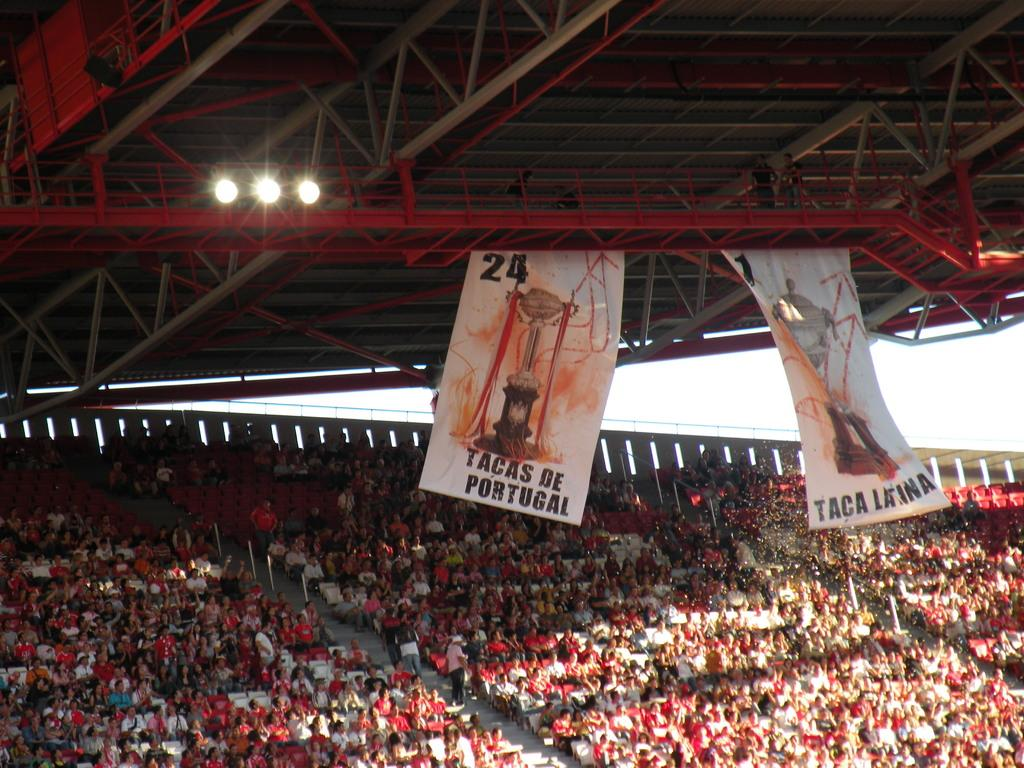<image>
Summarize the visual content of the image. Two flags reading Tacas de Portugal and Taca Latina hang over the audience in a huge auditorium. 